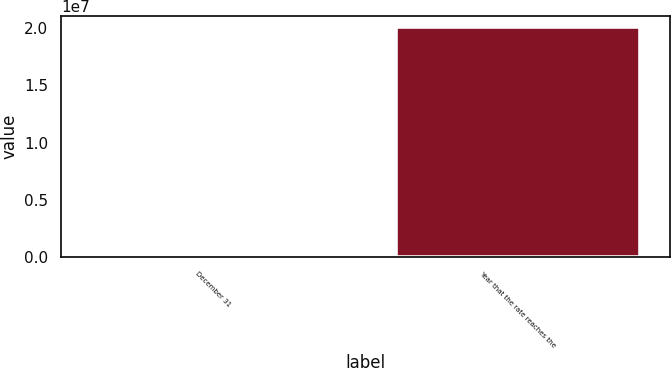Convert chart to OTSL. <chart><loc_0><loc_0><loc_500><loc_500><bar_chart><fcel>December 31<fcel>Year that the rate reaches the<nl><fcel>2004<fcel>2.0052e+07<nl></chart> 